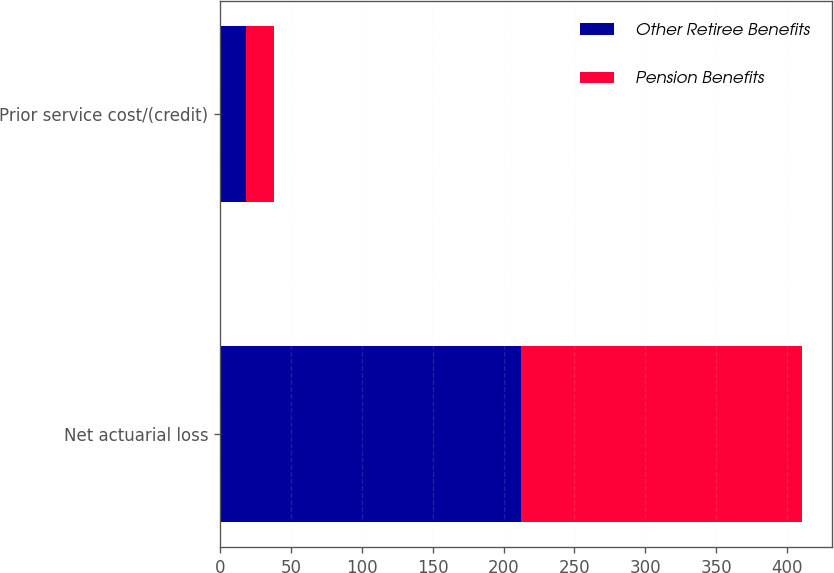Convert chart to OTSL. <chart><loc_0><loc_0><loc_500><loc_500><stacked_bar_chart><ecel><fcel>Net actuarial loss<fcel>Prior service cost/(credit)<nl><fcel>Other Retiree Benefits<fcel>212<fcel>18<nl><fcel>Pension Benefits<fcel>199<fcel>20<nl></chart> 